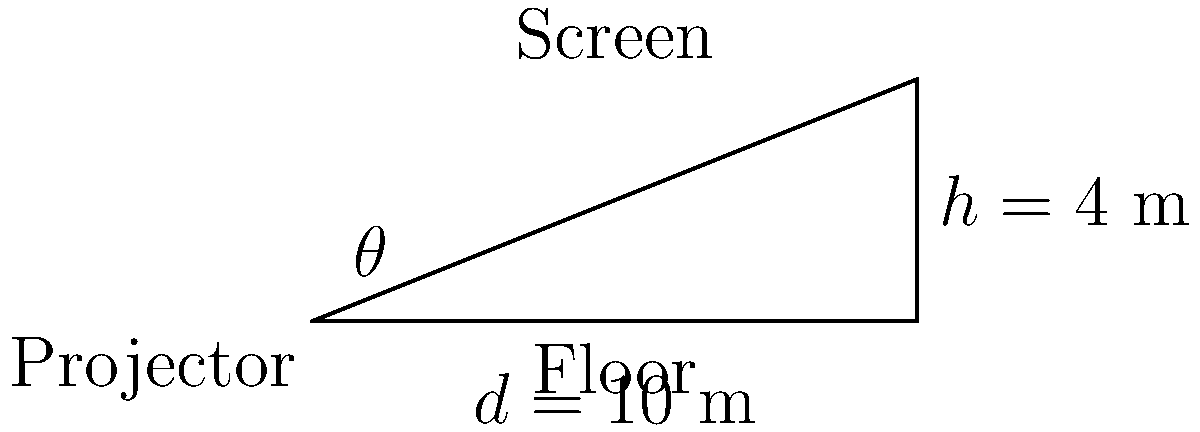In a classic cinema setup, a projector needs to be positioned to display the image on a screen. The screen is 4 meters high, and the projector is placed 10 meters away from the base of the screen. What is the angle of inclination (θ) at which the projector should be tilted to properly align with the top of the screen? To find the angle of inclination (θ), we can use trigonometry, specifically the tangent function. Let's approach this step-by-step:

1. Identify the right triangle:
   - The floor forms the base (adjacent side)
   - The height of the screen forms the opposite side
   - The line from the projector to the top of the screen forms the hypotenuse

2. We know:
   - Opposite side (height) = 4 meters
   - Adjacent side (distance) = 10 meters

3. The tangent of an angle is defined as the ratio of the opposite side to the adjacent side:

   $$\tan(\theta) = \frac{\text{opposite}}{\text{adjacent}} = \frac{\text{height}}{\text{distance}}$$

4. Substituting our values:

   $$\tan(\theta) = \frac{4}{10} = 0.4$$

5. To find θ, we need to use the inverse tangent (arctan or tan^(-1)):

   $$\theta = \tan^{-1}(0.4)$$

6. Using a calculator or trigonometric tables:

   $$\theta \approx 21.8^\circ$$

Therefore, the projector should be tilted at an angle of approximately 21.8 degrees to properly align with the top of the screen.
Answer: 21.8° 